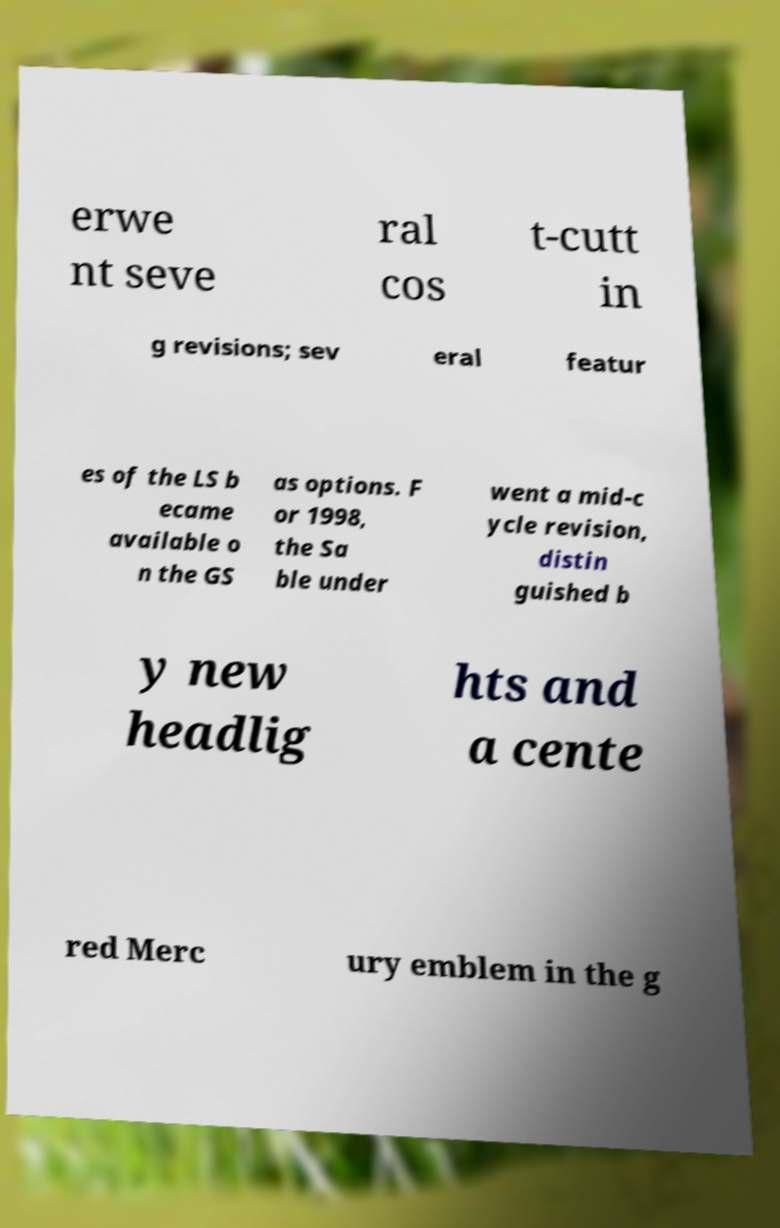Can you accurately transcribe the text from the provided image for me? erwe nt seve ral cos t-cutt in g revisions; sev eral featur es of the LS b ecame available o n the GS as options. F or 1998, the Sa ble under went a mid-c ycle revision, distin guished b y new headlig hts and a cente red Merc ury emblem in the g 